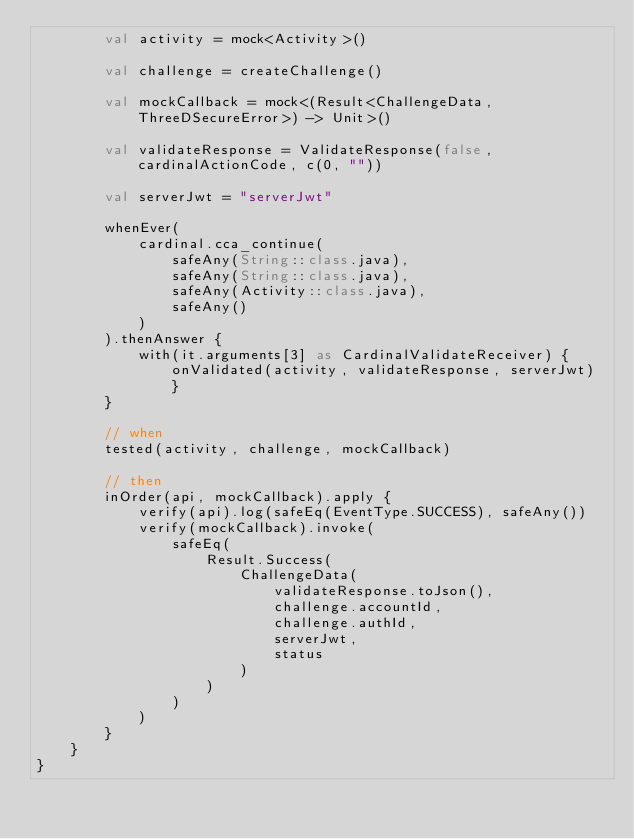<code> <loc_0><loc_0><loc_500><loc_500><_Kotlin_>        val activity = mock<Activity>()

        val challenge = createChallenge()

        val mockCallback = mock<(Result<ChallengeData, ThreeDSecureError>) -> Unit>()

        val validateResponse = ValidateResponse(false, cardinalActionCode, c(0, ""))

        val serverJwt = "serverJwt"

        whenEver(
            cardinal.cca_continue(
                safeAny(String::class.java),
                safeAny(String::class.java),
                safeAny(Activity::class.java),
                safeAny()
            )
        ).thenAnswer {
            with(it.arguments[3] as CardinalValidateReceiver) { onValidated(activity, validateResponse, serverJwt) }
        }

        // when
        tested(activity, challenge, mockCallback)

        // then
        inOrder(api, mockCallback).apply {
            verify(api).log(safeEq(EventType.SUCCESS), safeAny())
            verify(mockCallback).invoke(
                safeEq(
                    Result.Success(
                        ChallengeData(
                            validateResponse.toJson(),
                            challenge.accountId,
                            challenge.authId,
                            serverJwt,
                            status
                        )
                    )
                )
            )
        }
    }
}</code> 